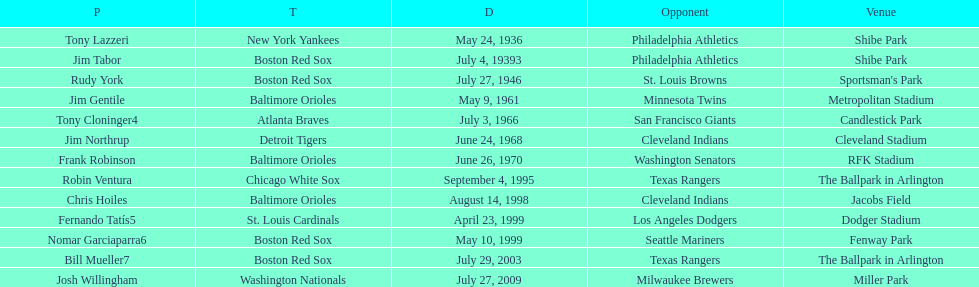What was the name of the player who accomplished this in 1999 but played for the boston red sox? Nomar Garciaparra. Would you be able to parse every entry in this table? {'header': ['P', 'T', 'D', 'Opponent', 'Venue'], 'rows': [['Tony Lazzeri', 'New York Yankees', 'May 24, 1936', 'Philadelphia Athletics', 'Shibe Park'], ['Jim Tabor', 'Boston Red Sox', 'July 4, 19393', 'Philadelphia Athletics', 'Shibe Park'], ['Rudy York', 'Boston Red Sox', 'July 27, 1946', 'St. Louis Browns', "Sportsman's Park"], ['Jim Gentile', 'Baltimore Orioles', 'May 9, 1961', 'Minnesota Twins', 'Metropolitan Stadium'], ['Tony Cloninger4', 'Atlanta Braves', 'July 3, 1966', 'San Francisco Giants', 'Candlestick Park'], ['Jim Northrup', 'Detroit Tigers', 'June 24, 1968', 'Cleveland Indians', 'Cleveland Stadium'], ['Frank Robinson', 'Baltimore Orioles', 'June 26, 1970', 'Washington Senators', 'RFK Stadium'], ['Robin Ventura', 'Chicago White Sox', 'September 4, 1995', 'Texas Rangers', 'The Ballpark in Arlington'], ['Chris Hoiles', 'Baltimore Orioles', 'August 14, 1998', 'Cleveland Indians', 'Jacobs Field'], ['Fernando Tatís5', 'St. Louis Cardinals', 'April 23, 1999', 'Los Angeles Dodgers', 'Dodger Stadium'], ['Nomar Garciaparra6', 'Boston Red Sox', 'May 10, 1999', 'Seattle Mariners', 'Fenway Park'], ['Bill Mueller7', 'Boston Red Sox', 'July 29, 2003', 'Texas Rangers', 'The Ballpark in Arlington'], ['Josh Willingham', 'Washington Nationals', 'July 27, 2009', 'Milwaukee Brewers', 'Miller Park']]} 